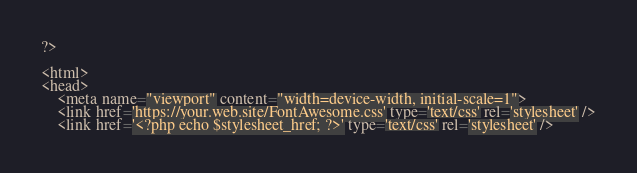<code> <loc_0><loc_0><loc_500><loc_500><_HTML_>
?>

<html>
<head>
	<meta name="viewport" content="width=device-width, initial-scale=1">
	<link href='https://your.web.site/FontAwesome.css' type='text/css' rel='stylesheet' />
	<link href='<?php echo $stylesheet_href; ?>' type='text/css' rel='stylesheet' /></code> 